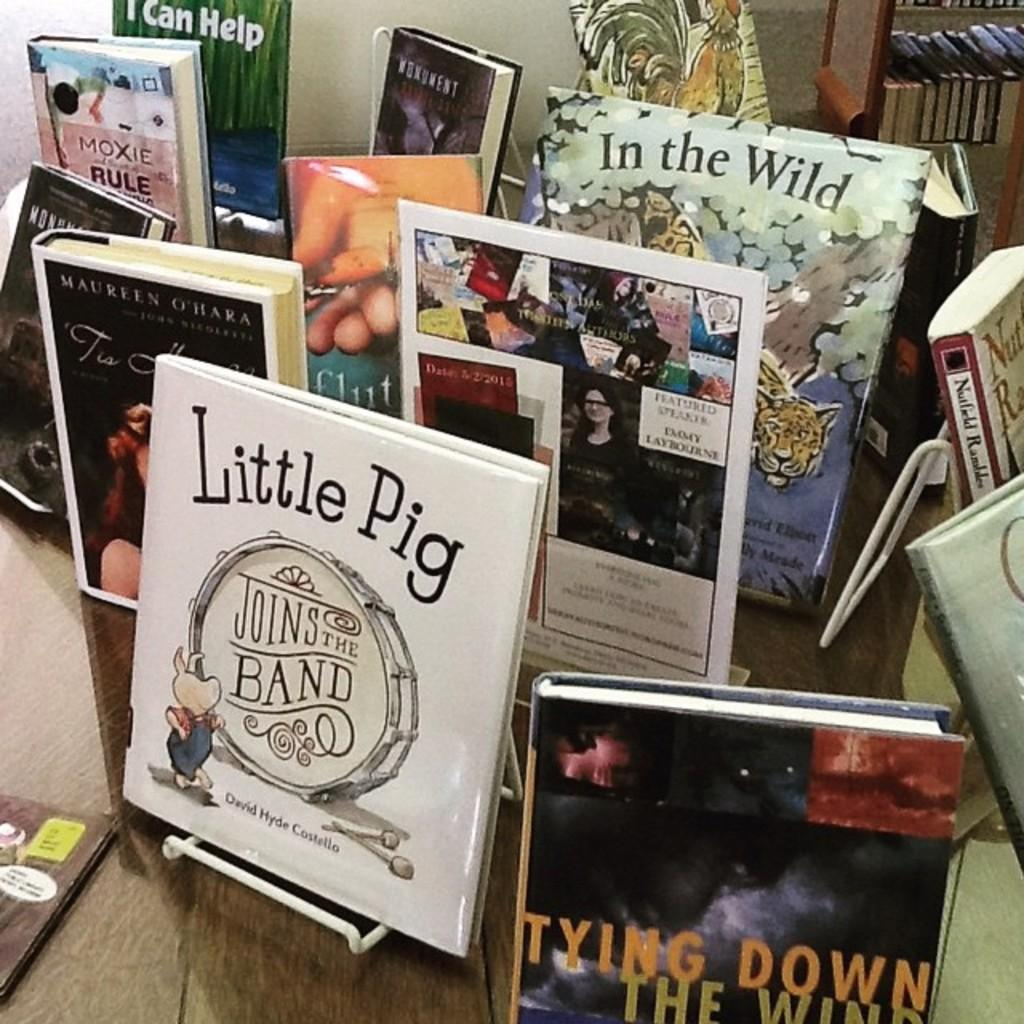<image>
Offer a succinct explanation of the picture presented. books on racks with one named 'little pig joins the band' 